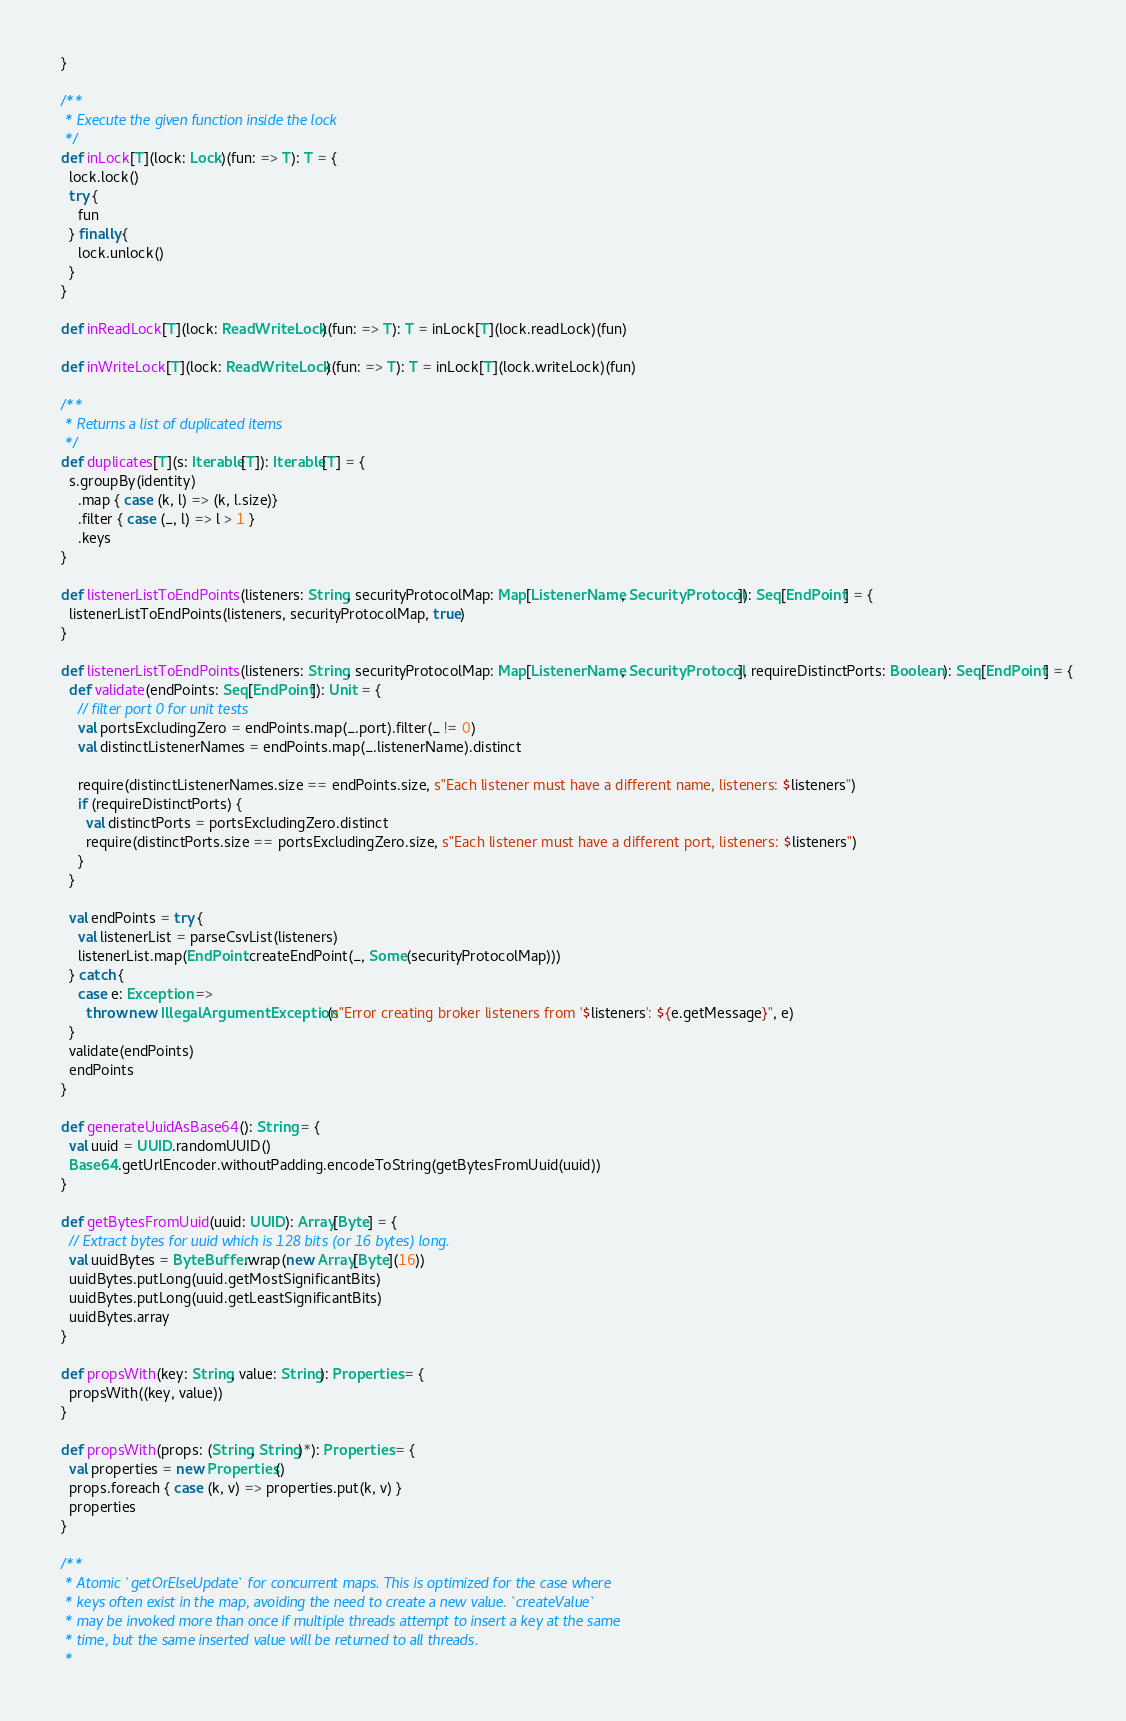<code> <loc_0><loc_0><loc_500><loc_500><_Scala_>  }

  /**
   * Execute the given function inside the lock
   */
  def inLock[T](lock: Lock)(fun: => T): T = {
    lock.lock()
    try {
      fun
    } finally {
      lock.unlock()
    }
  }

  def inReadLock[T](lock: ReadWriteLock)(fun: => T): T = inLock[T](lock.readLock)(fun)

  def inWriteLock[T](lock: ReadWriteLock)(fun: => T): T = inLock[T](lock.writeLock)(fun)

  /**
   * Returns a list of duplicated items
   */
  def duplicates[T](s: Iterable[T]): Iterable[T] = {
    s.groupBy(identity)
      .map { case (k, l) => (k, l.size)}
      .filter { case (_, l) => l > 1 }
      .keys
  }

  def listenerListToEndPoints(listeners: String, securityProtocolMap: Map[ListenerName, SecurityProtocol]): Seq[EndPoint] = {
    listenerListToEndPoints(listeners, securityProtocolMap, true)
  }

  def listenerListToEndPoints(listeners: String, securityProtocolMap: Map[ListenerName, SecurityProtocol], requireDistinctPorts: Boolean): Seq[EndPoint] = {
    def validate(endPoints: Seq[EndPoint]): Unit = {
      // filter port 0 for unit tests
      val portsExcludingZero = endPoints.map(_.port).filter(_ != 0)
      val distinctListenerNames = endPoints.map(_.listenerName).distinct

      require(distinctListenerNames.size == endPoints.size, s"Each listener must have a different name, listeners: $listeners")
      if (requireDistinctPorts) {
        val distinctPorts = portsExcludingZero.distinct
        require(distinctPorts.size == portsExcludingZero.size, s"Each listener must have a different port, listeners: $listeners")
      }
    }

    val endPoints = try {
      val listenerList = parseCsvList(listeners)
      listenerList.map(EndPoint.createEndPoint(_, Some(securityProtocolMap)))
    } catch {
      case e: Exception =>
        throw new IllegalArgumentException(s"Error creating broker listeners from '$listeners': ${e.getMessage}", e)
    }
    validate(endPoints)
    endPoints
  }

  def generateUuidAsBase64(): String = {
    val uuid = UUID.randomUUID()
    Base64.getUrlEncoder.withoutPadding.encodeToString(getBytesFromUuid(uuid))
  }

  def getBytesFromUuid(uuid: UUID): Array[Byte] = {
    // Extract bytes for uuid which is 128 bits (or 16 bytes) long.
    val uuidBytes = ByteBuffer.wrap(new Array[Byte](16))
    uuidBytes.putLong(uuid.getMostSignificantBits)
    uuidBytes.putLong(uuid.getLeastSignificantBits)
    uuidBytes.array
  }

  def propsWith(key: String, value: String): Properties = {
    propsWith((key, value))
  }

  def propsWith(props: (String, String)*): Properties = {
    val properties = new Properties()
    props.foreach { case (k, v) => properties.put(k, v) }
    properties
  }

  /**
   * Atomic `getOrElseUpdate` for concurrent maps. This is optimized for the case where
   * keys often exist in the map, avoiding the need to create a new value. `createValue`
   * may be invoked more than once if multiple threads attempt to insert a key at the same
   * time, but the same inserted value will be returned to all threads.
   *</code> 